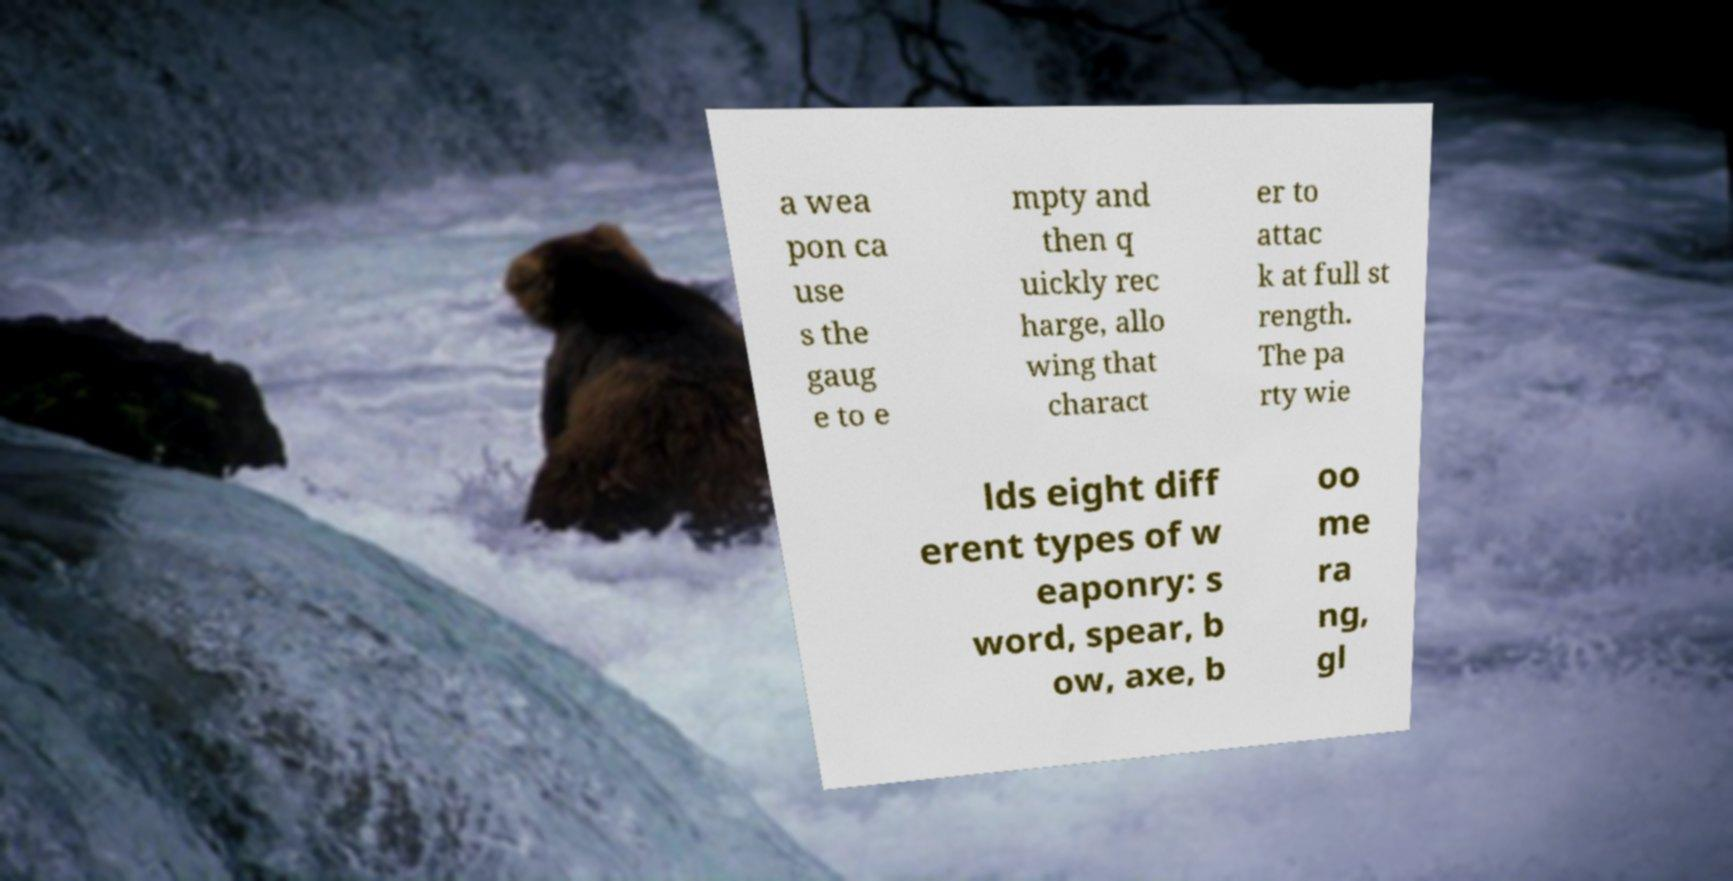Could you assist in decoding the text presented in this image and type it out clearly? a wea pon ca use s the gaug e to e mpty and then q uickly rec harge, allo wing that charact er to attac k at full st rength. The pa rty wie lds eight diff erent types of w eaponry: s word, spear, b ow, axe, b oo me ra ng, gl 